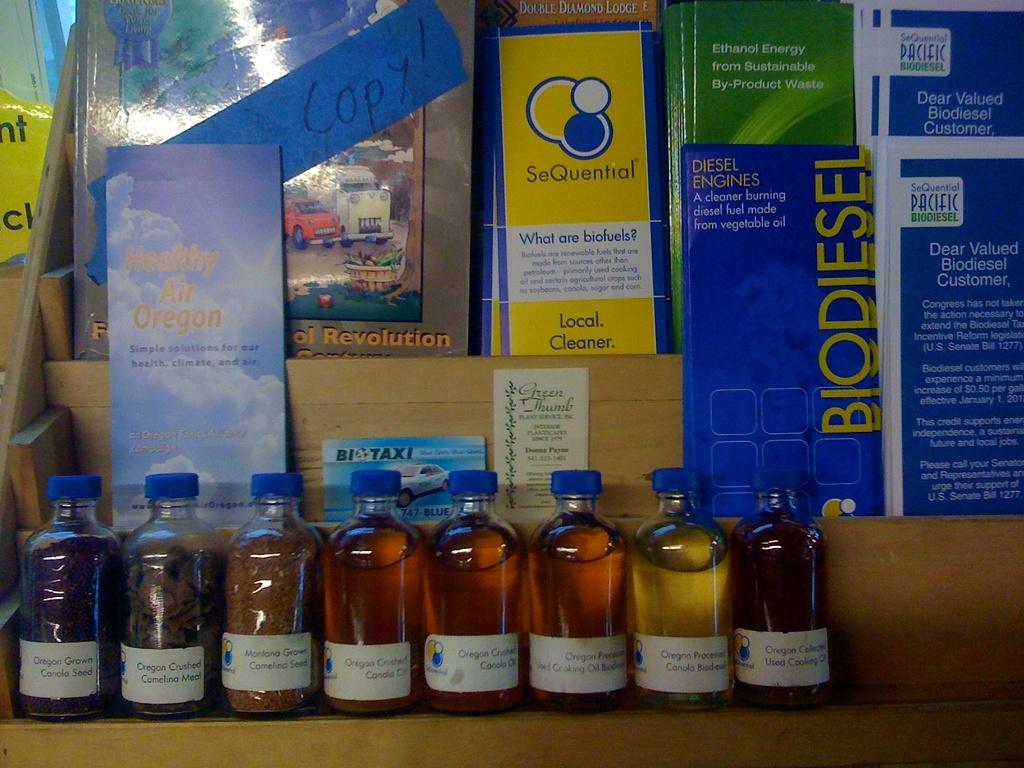<image>
Offer a succinct explanation of the picture presented. A brochure about biodiesel sits on a counter 